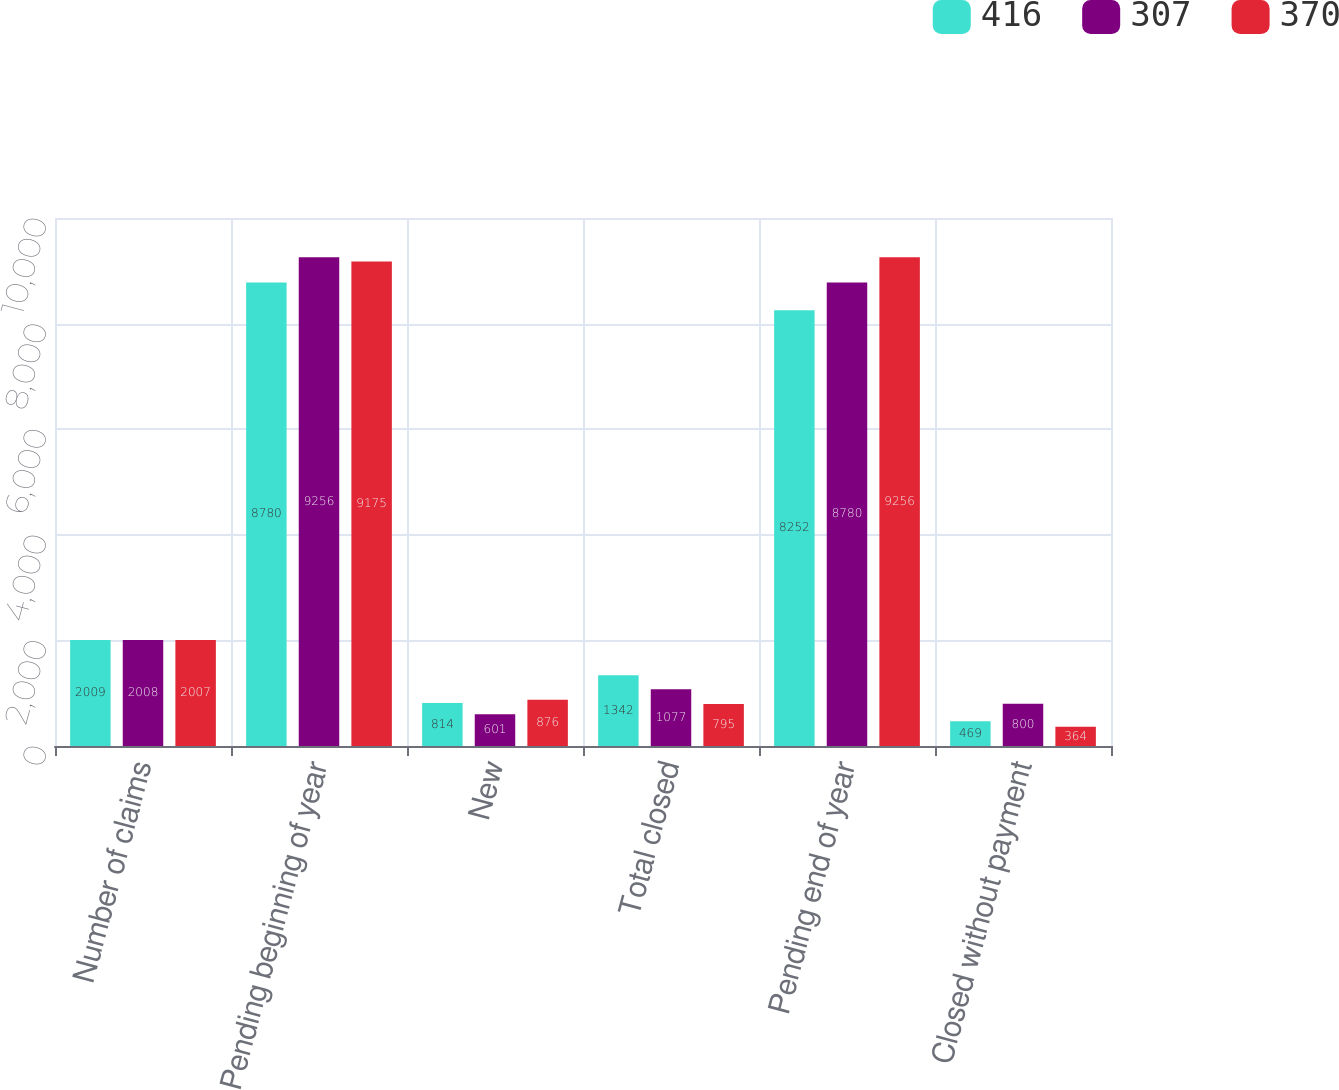Convert chart to OTSL. <chart><loc_0><loc_0><loc_500><loc_500><stacked_bar_chart><ecel><fcel>Number of claims<fcel>Pending beginning of year<fcel>New<fcel>Total closed<fcel>Pending end of year<fcel>Closed without payment<nl><fcel>416<fcel>2009<fcel>8780<fcel>814<fcel>1342<fcel>8252<fcel>469<nl><fcel>307<fcel>2008<fcel>9256<fcel>601<fcel>1077<fcel>8780<fcel>800<nl><fcel>370<fcel>2007<fcel>9175<fcel>876<fcel>795<fcel>9256<fcel>364<nl></chart> 